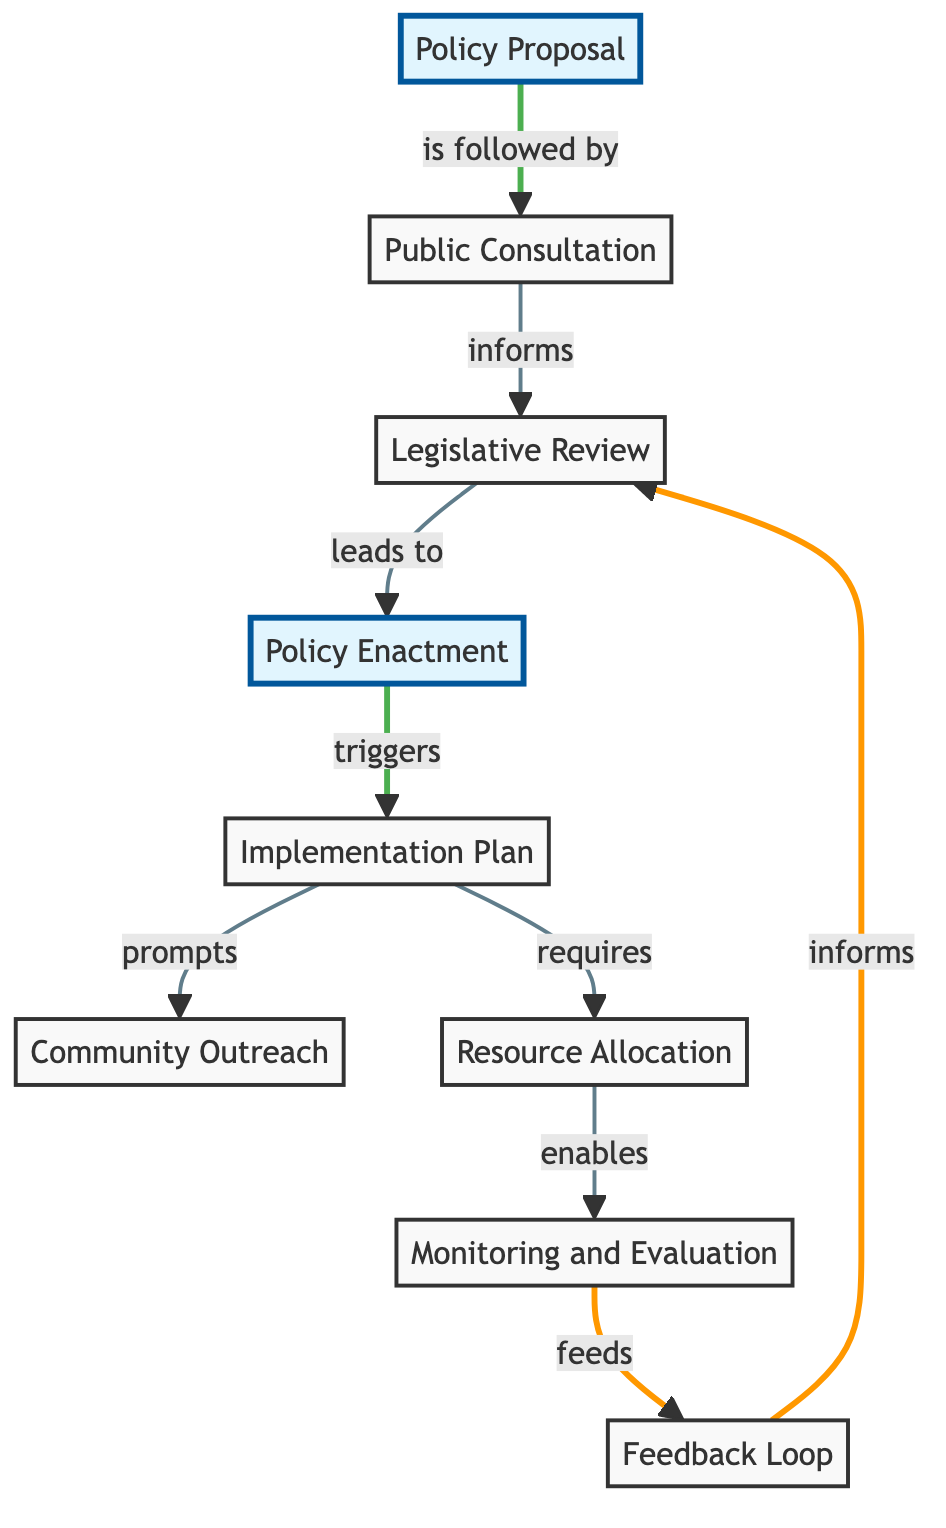What is the label of node 3? Node 3 is labeled "Legislative Review" as indicated in the node description section of the diagram's data.
Answer: Legislative Review How many nodes are present in the diagram? The diagram contains a total of 9 nodes, as listed under the "nodes" section of the provided data.
Answer: 9 What is the relationship between node 4 and node 5? The relationship is described as "triggers," meaning node 4 ("Policy Enactment") leads to action in node 5 ("Implementation Plan").
Answer: triggers Which node follows directly after "Public Consultation"? According to the directed edge from node 2 to node 3, "Legislative Review" directly follows "Public Consultation."
Answer: Legislative Review What action does "Implementation Plan" prompt? The "Implementation Plan" prompts "Community Outreach" as indicated by the directed edge labeled "prompts" leading from node 5 to node 6.
Answer: Community Outreach How does "Monitoring and Evaluation" contribute to the legislative process? "Monitoring and Evaluation" feeds into the "Feedback Loop," meaning it contributes data and insights for future modifications of the legislation.
Answer: feeds What is the final node that receives input in this diagram? The last node to receive input is node 3 ("Legislative Review"), which receives feedback from node 9 ("Feedback Loop").
Answer: Legislative Review Which node is a result of the “Policy Enactment”? After "Policy Enactment," the next step indicated in the diagram is the "Implementation Plan," which is the result of the policy being enacted.
Answer: Implementation Plan Name the type of operation that comes after "Resource Allocation." The operation that follows "Resource Allocation" is "Monitoring and Evaluation," as indicated by the directed edge that starts from node 7 and ends at node 8.
Answer: Monitoring and Evaluation 